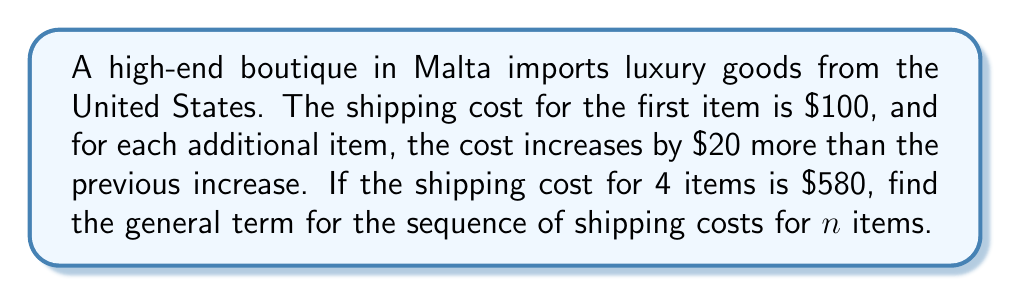What is the answer to this math problem? Let's approach this step-by-step:

1) First, let's identify the pattern in the shipping costs:
   1st item: $100
   2nd item: $100 + ($100 + $20) = $220
   3rd item: $220 + ($100 + $20 + $20) = $360
   4th item: $360 + ($100 + $20 + $20 + $20) = $580

2) We can see that the increase in cost for each item forms an arithmetic sequence:
   $100, $120, $140, $160, ...

3) The general term for an arithmetic sequence is $a_n = a_1 + (n-1)d$, where $a_1$ is the first term and $d$ is the common difference.

4) In this case, $a_1 = 100$ and $d = 20$

5) So, the increase for the nth item is: $100 + (n-1)20 = 20n + 80$

6) To get the total shipping cost for n items, we need to sum these increases:

   $$S_n = \sum_{i=1}^n (20i + 80)$$

7) Using the formula for the sum of an arithmetic sequence:

   $$S_n = \frac{n}{2}[2a + (n-1)d]$$

   Where $a = 100$ and $d = 20$

8) Substituting:

   $$S_n = \frac{n}{2}[200 + (n-1)20] = \frac{n}{2}[200 + 20n - 20] = \frac{n}{2}[180 + 20n]$$

9) Simplifying:

   $$S_n = 90n + 10n^2$$

Therefore, the general term for the sequence of shipping costs for n items is $90n + 10n^2$.
Answer: $90n + 10n^2$ 